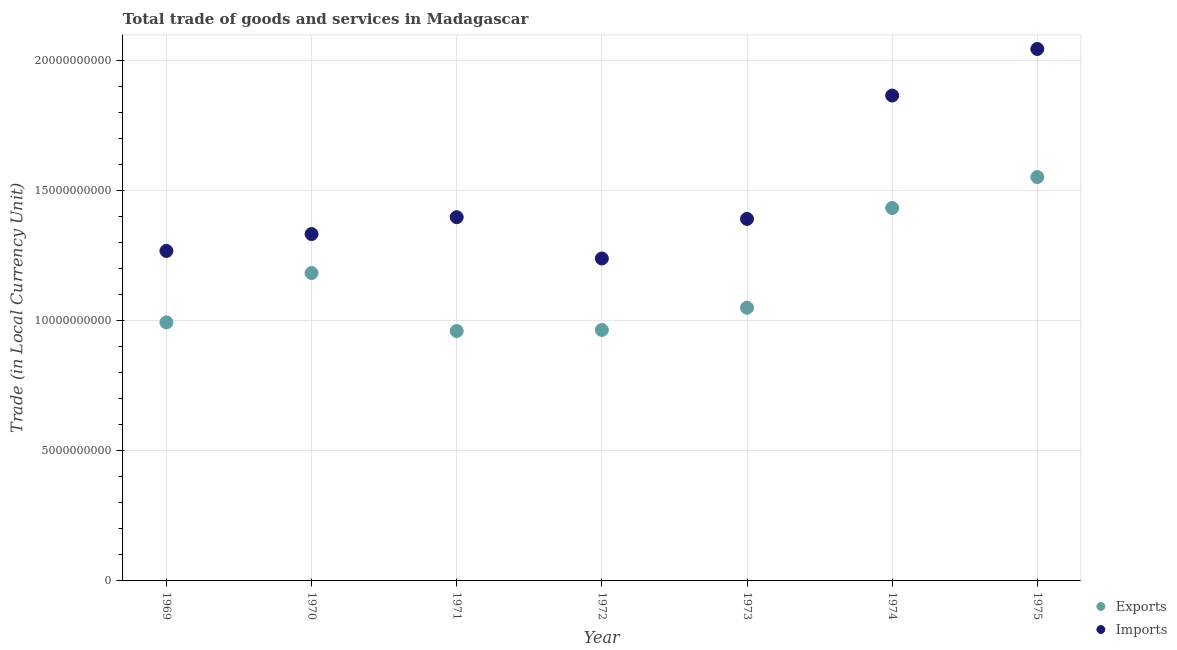Is the number of dotlines equal to the number of legend labels?
Provide a short and direct response. Yes. What is the imports of goods and services in 1973?
Provide a short and direct response. 1.39e+1. Across all years, what is the maximum imports of goods and services?
Your answer should be very brief. 2.04e+1. Across all years, what is the minimum imports of goods and services?
Provide a succinct answer. 1.24e+1. In which year was the imports of goods and services maximum?
Offer a very short reply. 1975. In which year was the imports of goods and services minimum?
Provide a short and direct response. 1972. What is the total imports of goods and services in the graph?
Keep it short and to the point. 1.05e+11. What is the difference between the export of goods and services in 1970 and that in 1971?
Your response must be concise. 2.23e+09. What is the difference between the imports of goods and services in 1974 and the export of goods and services in 1970?
Provide a succinct answer. 6.82e+09. What is the average export of goods and services per year?
Give a very brief answer. 1.16e+1. In the year 1975, what is the difference between the export of goods and services and imports of goods and services?
Ensure brevity in your answer.  -4.92e+09. What is the ratio of the export of goods and services in 1970 to that in 1975?
Provide a succinct answer. 0.76. What is the difference between the highest and the second highest imports of goods and services?
Offer a terse response. 1.79e+09. What is the difference between the highest and the lowest imports of goods and services?
Offer a terse response. 8.05e+09. Is the imports of goods and services strictly greater than the export of goods and services over the years?
Offer a terse response. Yes. Is the imports of goods and services strictly less than the export of goods and services over the years?
Keep it short and to the point. No. How many dotlines are there?
Your answer should be compact. 2. Are the values on the major ticks of Y-axis written in scientific E-notation?
Offer a very short reply. No. Does the graph contain any zero values?
Offer a very short reply. No. What is the title of the graph?
Your response must be concise. Total trade of goods and services in Madagascar. What is the label or title of the X-axis?
Your response must be concise. Year. What is the label or title of the Y-axis?
Your answer should be very brief. Trade (in Local Currency Unit). What is the Trade (in Local Currency Unit) of Exports in 1969?
Provide a succinct answer. 9.94e+09. What is the Trade (in Local Currency Unit) of Imports in 1969?
Your response must be concise. 1.27e+1. What is the Trade (in Local Currency Unit) of Exports in 1970?
Offer a very short reply. 1.18e+1. What is the Trade (in Local Currency Unit) in Imports in 1970?
Make the answer very short. 1.33e+1. What is the Trade (in Local Currency Unit) in Exports in 1971?
Ensure brevity in your answer.  9.60e+09. What is the Trade (in Local Currency Unit) in Imports in 1971?
Offer a terse response. 1.40e+1. What is the Trade (in Local Currency Unit) in Exports in 1972?
Offer a very short reply. 9.65e+09. What is the Trade (in Local Currency Unit) of Imports in 1972?
Your answer should be compact. 1.24e+1. What is the Trade (in Local Currency Unit) in Exports in 1973?
Offer a terse response. 1.05e+1. What is the Trade (in Local Currency Unit) of Imports in 1973?
Provide a short and direct response. 1.39e+1. What is the Trade (in Local Currency Unit) in Exports in 1974?
Offer a terse response. 1.43e+1. What is the Trade (in Local Currency Unit) in Imports in 1974?
Make the answer very short. 1.87e+1. What is the Trade (in Local Currency Unit) of Exports in 1975?
Keep it short and to the point. 1.55e+1. What is the Trade (in Local Currency Unit) in Imports in 1975?
Provide a succinct answer. 2.04e+1. Across all years, what is the maximum Trade (in Local Currency Unit) in Exports?
Your answer should be very brief. 1.55e+1. Across all years, what is the maximum Trade (in Local Currency Unit) in Imports?
Keep it short and to the point. 2.04e+1. Across all years, what is the minimum Trade (in Local Currency Unit) of Exports?
Provide a short and direct response. 9.60e+09. Across all years, what is the minimum Trade (in Local Currency Unit) in Imports?
Make the answer very short. 1.24e+1. What is the total Trade (in Local Currency Unit) in Exports in the graph?
Your response must be concise. 8.14e+1. What is the total Trade (in Local Currency Unit) of Imports in the graph?
Give a very brief answer. 1.05e+11. What is the difference between the Trade (in Local Currency Unit) of Exports in 1969 and that in 1970?
Your response must be concise. -1.90e+09. What is the difference between the Trade (in Local Currency Unit) of Imports in 1969 and that in 1970?
Offer a terse response. -6.49e+08. What is the difference between the Trade (in Local Currency Unit) of Exports in 1969 and that in 1971?
Your answer should be compact. 3.33e+08. What is the difference between the Trade (in Local Currency Unit) of Imports in 1969 and that in 1971?
Give a very brief answer. -1.30e+09. What is the difference between the Trade (in Local Currency Unit) of Exports in 1969 and that in 1972?
Provide a short and direct response. 2.92e+08. What is the difference between the Trade (in Local Currency Unit) in Imports in 1969 and that in 1972?
Keep it short and to the point. 2.91e+08. What is the difference between the Trade (in Local Currency Unit) in Exports in 1969 and that in 1973?
Provide a short and direct response. -5.62e+08. What is the difference between the Trade (in Local Currency Unit) in Imports in 1969 and that in 1973?
Ensure brevity in your answer.  -1.23e+09. What is the difference between the Trade (in Local Currency Unit) in Exports in 1969 and that in 1974?
Keep it short and to the point. -4.40e+09. What is the difference between the Trade (in Local Currency Unit) in Imports in 1969 and that in 1974?
Your response must be concise. -5.97e+09. What is the difference between the Trade (in Local Currency Unit) in Exports in 1969 and that in 1975?
Give a very brief answer. -5.58e+09. What is the difference between the Trade (in Local Currency Unit) in Imports in 1969 and that in 1975?
Your answer should be compact. -7.76e+09. What is the difference between the Trade (in Local Currency Unit) in Exports in 1970 and that in 1971?
Keep it short and to the point. 2.23e+09. What is the difference between the Trade (in Local Currency Unit) in Imports in 1970 and that in 1971?
Offer a very short reply. -6.49e+08. What is the difference between the Trade (in Local Currency Unit) in Exports in 1970 and that in 1972?
Give a very brief answer. 2.19e+09. What is the difference between the Trade (in Local Currency Unit) of Imports in 1970 and that in 1972?
Provide a succinct answer. 9.39e+08. What is the difference between the Trade (in Local Currency Unit) of Exports in 1970 and that in 1973?
Ensure brevity in your answer.  1.33e+09. What is the difference between the Trade (in Local Currency Unit) of Imports in 1970 and that in 1973?
Offer a very short reply. -5.82e+08. What is the difference between the Trade (in Local Currency Unit) in Exports in 1970 and that in 1974?
Your response must be concise. -2.50e+09. What is the difference between the Trade (in Local Currency Unit) in Imports in 1970 and that in 1974?
Your response must be concise. -5.32e+09. What is the difference between the Trade (in Local Currency Unit) of Exports in 1970 and that in 1975?
Ensure brevity in your answer.  -3.69e+09. What is the difference between the Trade (in Local Currency Unit) of Imports in 1970 and that in 1975?
Your response must be concise. -7.11e+09. What is the difference between the Trade (in Local Currency Unit) of Exports in 1971 and that in 1972?
Keep it short and to the point. -4.17e+07. What is the difference between the Trade (in Local Currency Unit) of Imports in 1971 and that in 1972?
Provide a succinct answer. 1.59e+09. What is the difference between the Trade (in Local Currency Unit) in Exports in 1971 and that in 1973?
Offer a very short reply. -8.96e+08. What is the difference between the Trade (in Local Currency Unit) in Imports in 1971 and that in 1973?
Offer a terse response. 6.71e+07. What is the difference between the Trade (in Local Currency Unit) in Exports in 1971 and that in 1974?
Provide a short and direct response. -4.73e+09. What is the difference between the Trade (in Local Currency Unit) in Imports in 1971 and that in 1974?
Keep it short and to the point. -4.67e+09. What is the difference between the Trade (in Local Currency Unit) of Exports in 1971 and that in 1975?
Provide a succinct answer. -5.92e+09. What is the difference between the Trade (in Local Currency Unit) of Imports in 1971 and that in 1975?
Keep it short and to the point. -6.46e+09. What is the difference between the Trade (in Local Currency Unit) in Exports in 1972 and that in 1973?
Offer a terse response. -8.54e+08. What is the difference between the Trade (in Local Currency Unit) in Imports in 1972 and that in 1973?
Your response must be concise. -1.52e+09. What is the difference between the Trade (in Local Currency Unit) in Exports in 1972 and that in 1974?
Your answer should be very brief. -4.69e+09. What is the difference between the Trade (in Local Currency Unit) in Imports in 1972 and that in 1974?
Provide a short and direct response. -6.26e+09. What is the difference between the Trade (in Local Currency Unit) of Exports in 1972 and that in 1975?
Your answer should be very brief. -5.87e+09. What is the difference between the Trade (in Local Currency Unit) in Imports in 1972 and that in 1975?
Your response must be concise. -8.05e+09. What is the difference between the Trade (in Local Currency Unit) of Exports in 1973 and that in 1974?
Give a very brief answer. -3.83e+09. What is the difference between the Trade (in Local Currency Unit) in Imports in 1973 and that in 1974?
Make the answer very short. -4.74e+09. What is the difference between the Trade (in Local Currency Unit) in Exports in 1973 and that in 1975?
Ensure brevity in your answer.  -5.02e+09. What is the difference between the Trade (in Local Currency Unit) in Imports in 1973 and that in 1975?
Offer a very short reply. -6.53e+09. What is the difference between the Trade (in Local Currency Unit) of Exports in 1974 and that in 1975?
Offer a very short reply. -1.19e+09. What is the difference between the Trade (in Local Currency Unit) of Imports in 1974 and that in 1975?
Ensure brevity in your answer.  -1.79e+09. What is the difference between the Trade (in Local Currency Unit) in Exports in 1969 and the Trade (in Local Currency Unit) in Imports in 1970?
Give a very brief answer. -3.39e+09. What is the difference between the Trade (in Local Currency Unit) in Exports in 1969 and the Trade (in Local Currency Unit) in Imports in 1971?
Provide a succinct answer. -4.04e+09. What is the difference between the Trade (in Local Currency Unit) in Exports in 1969 and the Trade (in Local Currency Unit) in Imports in 1972?
Keep it short and to the point. -2.45e+09. What is the difference between the Trade (in Local Currency Unit) of Exports in 1969 and the Trade (in Local Currency Unit) of Imports in 1973?
Make the answer very short. -3.97e+09. What is the difference between the Trade (in Local Currency Unit) of Exports in 1969 and the Trade (in Local Currency Unit) of Imports in 1974?
Make the answer very short. -8.72e+09. What is the difference between the Trade (in Local Currency Unit) of Exports in 1969 and the Trade (in Local Currency Unit) of Imports in 1975?
Your answer should be very brief. -1.05e+1. What is the difference between the Trade (in Local Currency Unit) in Exports in 1970 and the Trade (in Local Currency Unit) in Imports in 1971?
Offer a very short reply. -2.15e+09. What is the difference between the Trade (in Local Currency Unit) of Exports in 1970 and the Trade (in Local Currency Unit) of Imports in 1972?
Provide a succinct answer. -5.58e+08. What is the difference between the Trade (in Local Currency Unit) of Exports in 1970 and the Trade (in Local Currency Unit) of Imports in 1973?
Your answer should be compact. -2.08e+09. What is the difference between the Trade (in Local Currency Unit) in Exports in 1970 and the Trade (in Local Currency Unit) in Imports in 1974?
Give a very brief answer. -6.82e+09. What is the difference between the Trade (in Local Currency Unit) in Exports in 1970 and the Trade (in Local Currency Unit) in Imports in 1975?
Your response must be concise. -8.61e+09. What is the difference between the Trade (in Local Currency Unit) of Exports in 1971 and the Trade (in Local Currency Unit) of Imports in 1972?
Make the answer very short. -2.79e+09. What is the difference between the Trade (in Local Currency Unit) of Exports in 1971 and the Trade (in Local Currency Unit) of Imports in 1973?
Offer a very short reply. -4.31e+09. What is the difference between the Trade (in Local Currency Unit) in Exports in 1971 and the Trade (in Local Currency Unit) in Imports in 1974?
Provide a succinct answer. -9.05e+09. What is the difference between the Trade (in Local Currency Unit) of Exports in 1971 and the Trade (in Local Currency Unit) of Imports in 1975?
Offer a very short reply. -1.08e+1. What is the difference between the Trade (in Local Currency Unit) in Exports in 1972 and the Trade (in Local Currency Unit) in Imports in 1973?
Your answer should be very brief. -4.27e+09. What is the difference between the Trade (in Local Currency Unit) in Exports in 1972 and the Trade (in Local Currency Unit) in Imports in 1974?
Your answer should be very brief. -9.01e+09. What is the difference between the Trade (in Local Currency Unit) in Exports in 1972 and the Trade (in Local Currency Unit) in Imports in 1975?
Your answer should be compact. -1.08e+1. What is the difference between the Trade (in Local Currency Unit) of Exports in 1973 and the Trade (in Local Currency Unit) of Imports in 1974?
Give a very brief answer. -8.15e+09. What is the difference between the Trade (in Local Currency Unit) of Exports in 1973 and the Trade (in Local Currency Unit) of Imports in 1975?
Your response must be concise. -9.94e+09. What is the difference between the Trade (in Local Currency Unit) in Exports in 1974 and the Trade (in Local Currency Unit) in Imports in 1975?
Give a very brief answer. -6.11e+09. What is the average Trade (in Local Currency Unit) of Exports per year?
Provide a short and direct response. 1.16e+1. What is the average Trade (in Local Currency Unit) in Imports per year?
Make the answer very short. 1.51e+1. In the year 1969, what is the difference between the Trade (in Local Currency Unit) in Exports and Trade (in Local Currency Unit) in Imports?
Give a very brief answer. -2.74e+09. In the year 1970, what is the difference between the Trade (in Local Currency Unit) of Exports and Trade (in Local Currency Unit) of Imports?
Provide a succinct answer. -1.50e+09. In the year 1971, what is the difference between the Trade (in Local Currency Unit) in Exports and Trade (in Local Currency Unit) in Imports?
Your response must be concise. -4.38e+09. In the year 1972, what is the difference between the Trade (in Local Currency Unit) in Exports and Trade (in Local Currency Unit) in Imports?
Make the answer very short. -2.75e+09. In the year 1973, what is the difference between the Trade (in Local Currency Unit) of Exports and Trade (in Local Currency Unit) of Imports?
Offer a terse response. -3.41e+09. In the year 1974, what is the difference between the Trade (in Local Currency Unit) in Exports and Trade (in Local Currency Unit) in Imports?
Your answer should be compact. -4.32e+09. In the year 1975, what is the difference between the Trade (in Local Currency Unit) in Exports and Trade (in Local Currency Unit) in Imports?
Your answer should be compact. -4.92e+09. What is the ratio of the Trade (in Local Currency Unit) of Exports in 1969 to that in 1970?
Your answer should be very brief. 0.84. What is the ratio of the Trade (in Local Currency Unit) of Imports in 1969 to that in 1970?
Make the answer very short. 0.95. What is the ratio of the Trade (in Local Currency Unit) in Exports in 1969 to that in 1971?
Keep it short and to the point. 1.03. What is the ratio of the Trade (in Local Currency Unit) in Imports in 1969 to that in 1971?
Give a very brief answer. 0.91. What is the ratio of the Trade (in Local Currency Unit) in Exports in 1969 to that in 1972?
Your answer should be very brief. 1.03. What is the ratio of the Trade (in Local Currency Unit) in Imports in 1969 to that in 1972?
Offer a terse response. 1.02. What is the ratio of the Trade (in Local Currency Unit) of Exports in 1969 to that in 1973?
Provide a short and direct response. 0.95. What is the ratio of the Trade (in Local Currency Unit) of Imports in 1969 to that in 1973?
Ensure brevity in your answer.  0.91. What is the ratio of the Trade (in Local Currency Unit) of Exports in 1969 to that in 1974?
Your answer should be very brief. 0.69. What is the ratio of the Trade (in Local Currency Unit) of Imports in 1969 to that in 1974?
Your response must be concise. 0.68. What is the ratio of the Trade (in Local Currency Unit) of Exports in 1969 to that in 1975?
Make the answer very short. 0.64. What is the ratio of the Trade (in Local Currency Unit) of Imports in 1969 to that in 1975?
Make the answer very short. 0.62. What is the ratio of the Trade (in Local Currency Unit) in Exports in 1970 to that in 1971?
Make the answer very short. 1.23. What is the ratio of the Trade (in Local Currency Unit) in Imports in 1970 to that in 1971?
Keep it short and to the point. 0.95. What is the ratio of the Trade (in Local Currency Unit) in Exports in 1970 to that in 1972?
Give a very brief answer. 1.23. What is the ratio of the Trade (in Local Currency Unit) of Imports in 1970 to that in 1972?
Your answer should be compact. 1.08. What is the ratio of the Trade (in Local Currency Unit) of Exports in 1970 to that in 1973?
Offer a very short reply. 1.13. What is the ratio of the Trade (in Local Currency Unit) in Imports in 1970 to that in 1973?
Provide a succinct answer. 0.96. What is the ratio of the Trade (in Local Currency Unit) of Exports in 1970 to that in 1974?
Offer a very short reply. 0.83. What is the ratio of the Trade (in Local Currency Unit) of Imports in 1970 to that in 1974?
Your response must be concise. 0.71. What is the ratio of the Trade (in Local Currency Unit) in Exports in 1970 to that in 1975?
Give a very brief answer. 0.76. What is the ratio of the Trade (in Local Currency Unit) of Imports in 1970 to that in 1975?
Give a very brief answer. 0.65. What is the ratio of the Trade (in Local Currency Unit) of Exports in 1971 to that in 1972?
Offer a terse response. 1. What is the ratio of the Trade (in Local Currency Unit) in Imports in 1971 to that in 1972?
Make the answer very short. 1.13. What is the ratio of the Trade (in Local Currency Unit) in Exports in 1971 to that in 1973?
Give a very brief answer. 0.91. What is the ratio of the Trade (in Local Currency Unit) in Exports in 1971 to that in 1974?
Your answer should be compact. 0.67. What is the ratio of the Trade (in Local Currency Unit) in Imports in 1971 to that in 1974?
Your response must be concise. 0.75. What is the ratio of the Trade (in Local Currency Unit) in Exports in 1971 to that in 1975?
Give a very brief answer. 0.62. What is the ratio of the Trade (in Local Currency Unit) in Imports in 1971 to that in 1975?
Give a very brief answer. 0.68. What is the ratio of the Trade (in Local Currency Unit) in Exports in 1972 to that in 1973?
Ensure brevity in your answer.  0.92. What is the ratio of the Trade (in Local Currency Unit) of Imports in 1972 to that in 1973?
Ensure brevity in your answer.  0.89. What is the ratio of the Trade (in Local Currency Unit) in Exports in 1972 to that in 1974?
Provide a short and direct response. 0.67. What is the ratio of the Trade (in Local Currency Unit) of Imports in 1972 to that in 1974?
Your response must be concise. 0.66. What is the ratio of the Trade (in Local Currency Unit) in Exports in 1972 to that in 1975?
Your answer should be very brief. 0.62. What is the ratio of the Trade (in Local Currency Unit) in Imports in 1972 to that in 1975?
Provide a succinct answer. 0.61. What is the ratio of the Trade (in Local Currency Unit) of Exports in 1973 to that in 1974?
Your answer should be very brief. 0.73. What is the ratio of the Trade (in Local Currency Unit) of Imports in 1973 to that in 1974?
Provide a short and direct response. 0.75. What is the ratio of the Trade (in Local Currency Unit) of Exports in 1973 to that in 1975?
Provide a short and direct response. 0.68. What is the ratio of the Trade (in Local Currency Unit) in Imports in 1973 to that in 1975?
Make the answer very short. 0.68. What is the ratio of the Trade (in Local Currency Unit) in Exports in 1974 to that in 1975?
Offer a very short reply. 0.92. What is the ratio of the Trade (in Local Currency Unit) of Imports in 1974 to that in 1975?
Your answer should be compact. 0.91. What is the difference between the highest and the second highest Trade (in Local Currency Unit) of Exports?
Your response must be concise. 1.19e+09. What is the difference between the highest and the second highest Trade (in Local Currency Unit) of Imports?
Provide a succinct answer. 1.79e+09. What is the difference between the highest and the lowest Trade (in Local Currency Unit) in Exports?
Provide a short and direct response. 5.92e+09. What is the difference between the highest and the lowest Trade (in Local Currency Unit) of Imports?
Your response must be concise. 8.05e+09. 